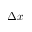<formula> <loc_0><loc_0><loc_500><loc_500>\Delta x</formula> 